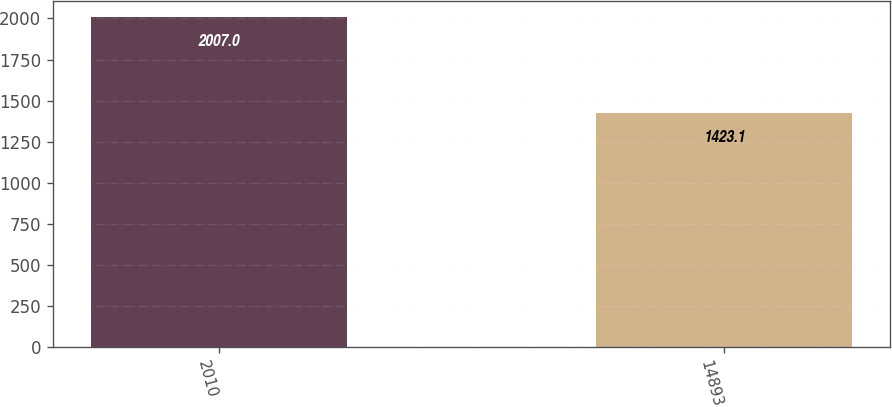Convert chart to OTSL. <chart><loc_0><loc_0><loc_500><loc_500><bar_chart><fcel>2010<fcel>14893<nl><fcel>2007<fcel>1423.1<nl></chart> 